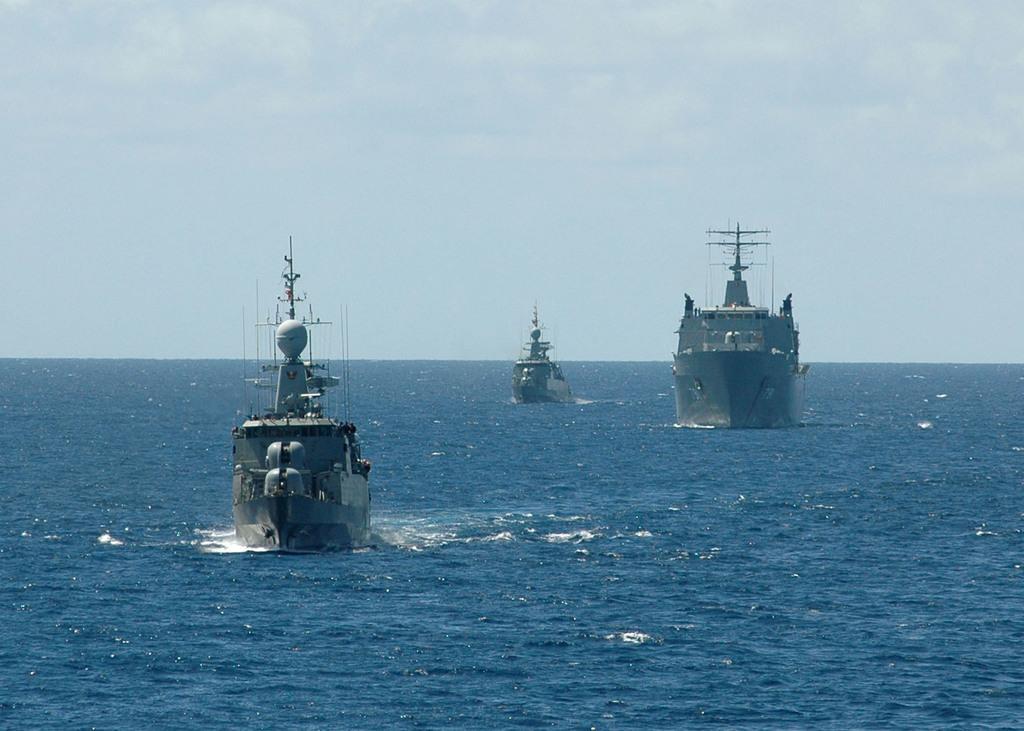Please provide a concise description of this image. In this image I can see few ships and blue color water. The sky is in blue and white color. 